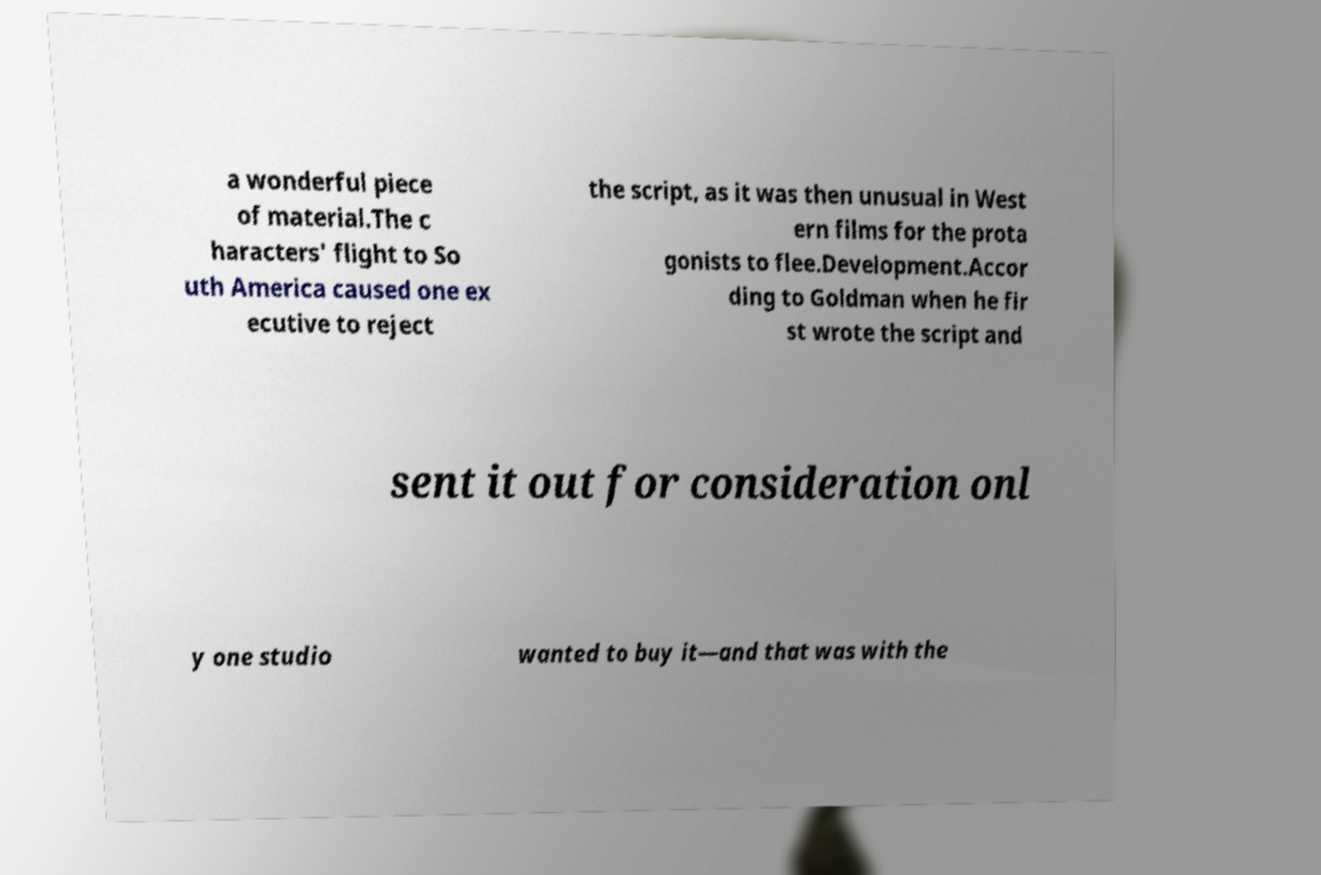Could you extract and type out the text from this image? a wonderful piece of material.The c haracters' flight to So uth America caused one ex ecutive to reject the script, as it was then unusual in West ern films for the prota gonists to flee.Development.Accor ding to Goldman when he fir st wrote the script and sent it out for consideration onl y one studio wanted to buy it—and that was with the 